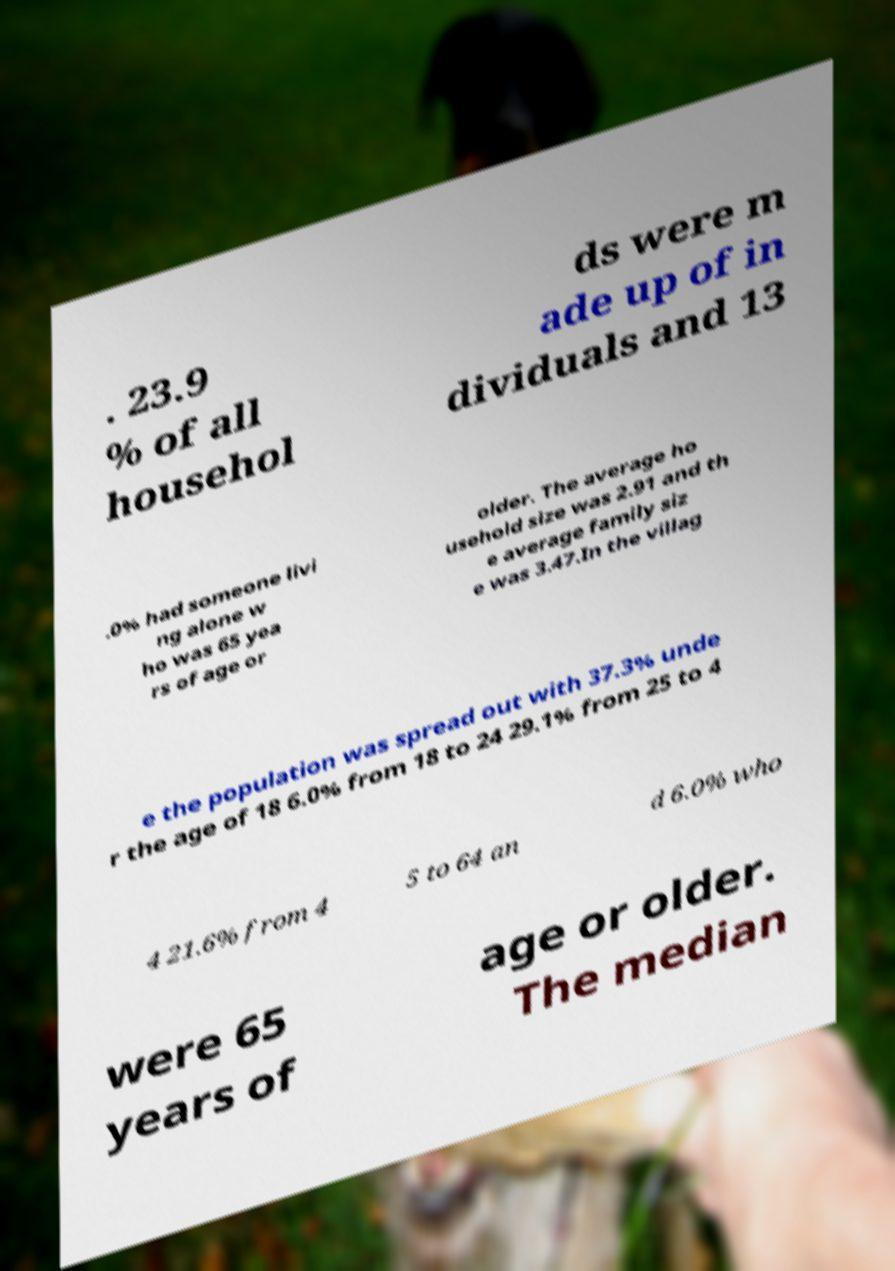Please read and relay the text visible in this image. What does it say? . 23.9 % of all househol ds were m ade up of in dividuals and 13 .0% had someone livi ng alone w ho was 65 yea rs of age or older. The average ho usehold size was 2.91 and th e average family siz e was 3.47.In the villag e the population was spread out with 37.3% unde r the age of 18 6.0% from 18 to 24 29.1% from 25 to 4 4 21.6% from 4 5 to 64 an d 6.0% who were 65 years of age or older. The median 